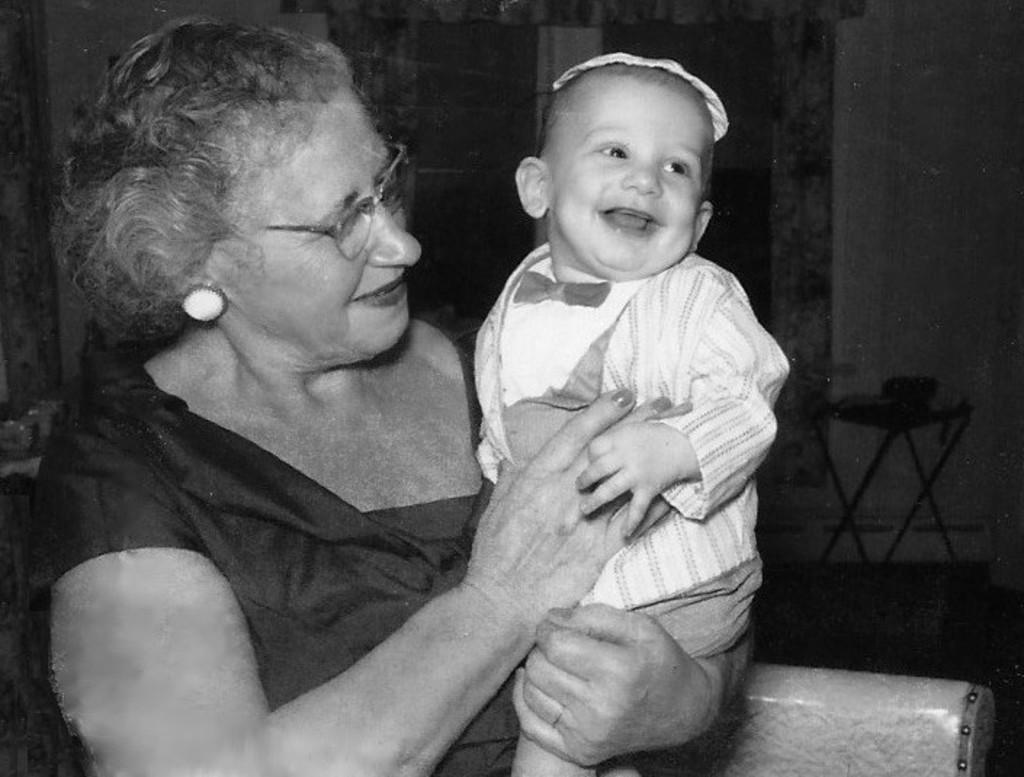What is the color scheme of the image? The image is black and white. What is the person in the image doing? The person is carrying a baby. Can you describe the background of the image? There are objects in the background of the image. What type of gate can be seen in the image? There is no gate present in the image. What thoughts are going through the person's mind while carrying the baby? The image does not provide any information about the person's thoughts, so we cannot determine what they might be thinking. 